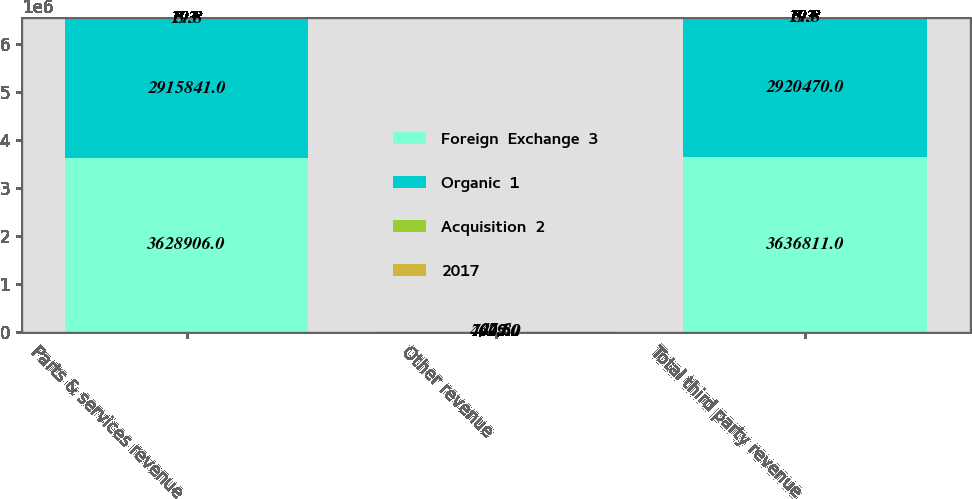Convert chart. <chart><loc_0><loc_0><loc_500><loc_500><stacked_bar_chart><ecel><fcel>Parts & services revenue<fcel>Other revenue<fcel>Total third party revenue<nl><fcel>Foreign  Exchange  3<fcel>3.62891e+06<fcel>7905<fcel>3.63681e+06<nl><fcel>Organic  1<fcel>2.91584e+06<fcel>4629<fcel>2.92047e+06<nl><fcel>Acquisition  2<fcel>5.3<fcel>47.6<fcel>5.3<nl><fcel>2017<fcel>19.8<fcel>24.8<fcel>19.8<nl></chart> 